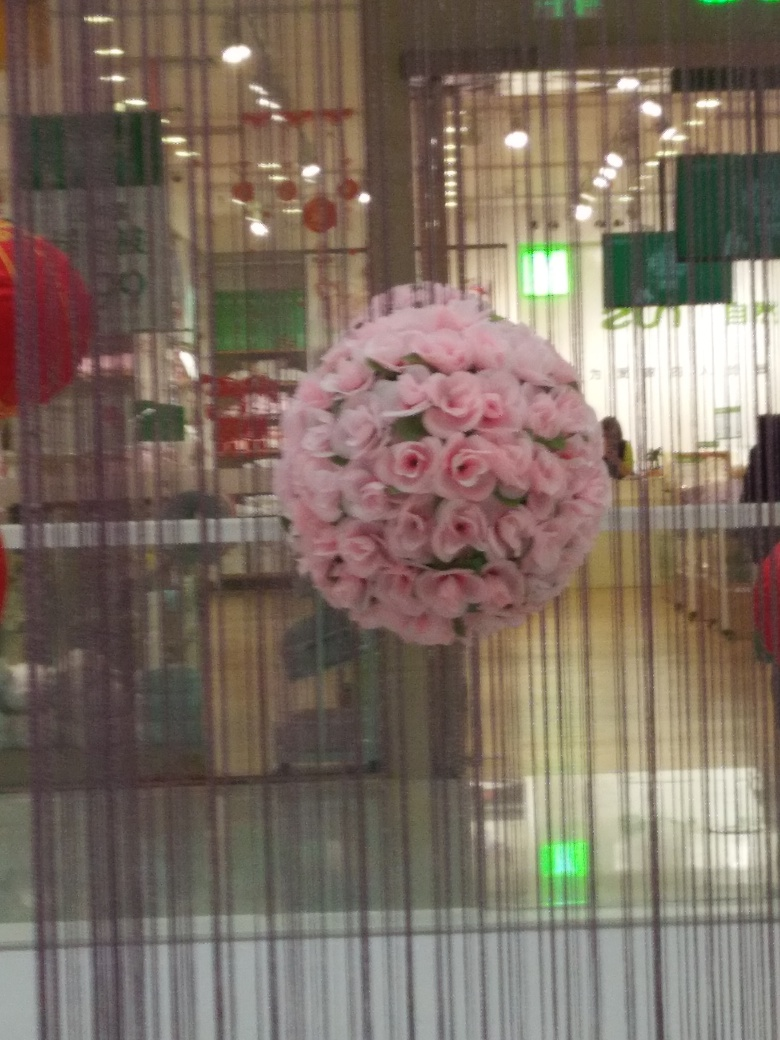What time of day does it look like this photo was taken? The lighting in the image is artificial, suggesting it could be any time during operating hours of the indoor facility. However, the empty chairs and the general quietness hint at a time that is either early before the establishment is busy, or later when it's less crowded. 